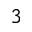Convert formula to latex. <formula><loc_0><loc_0><loc_500><loc_500>_ { 3 }</formula> 